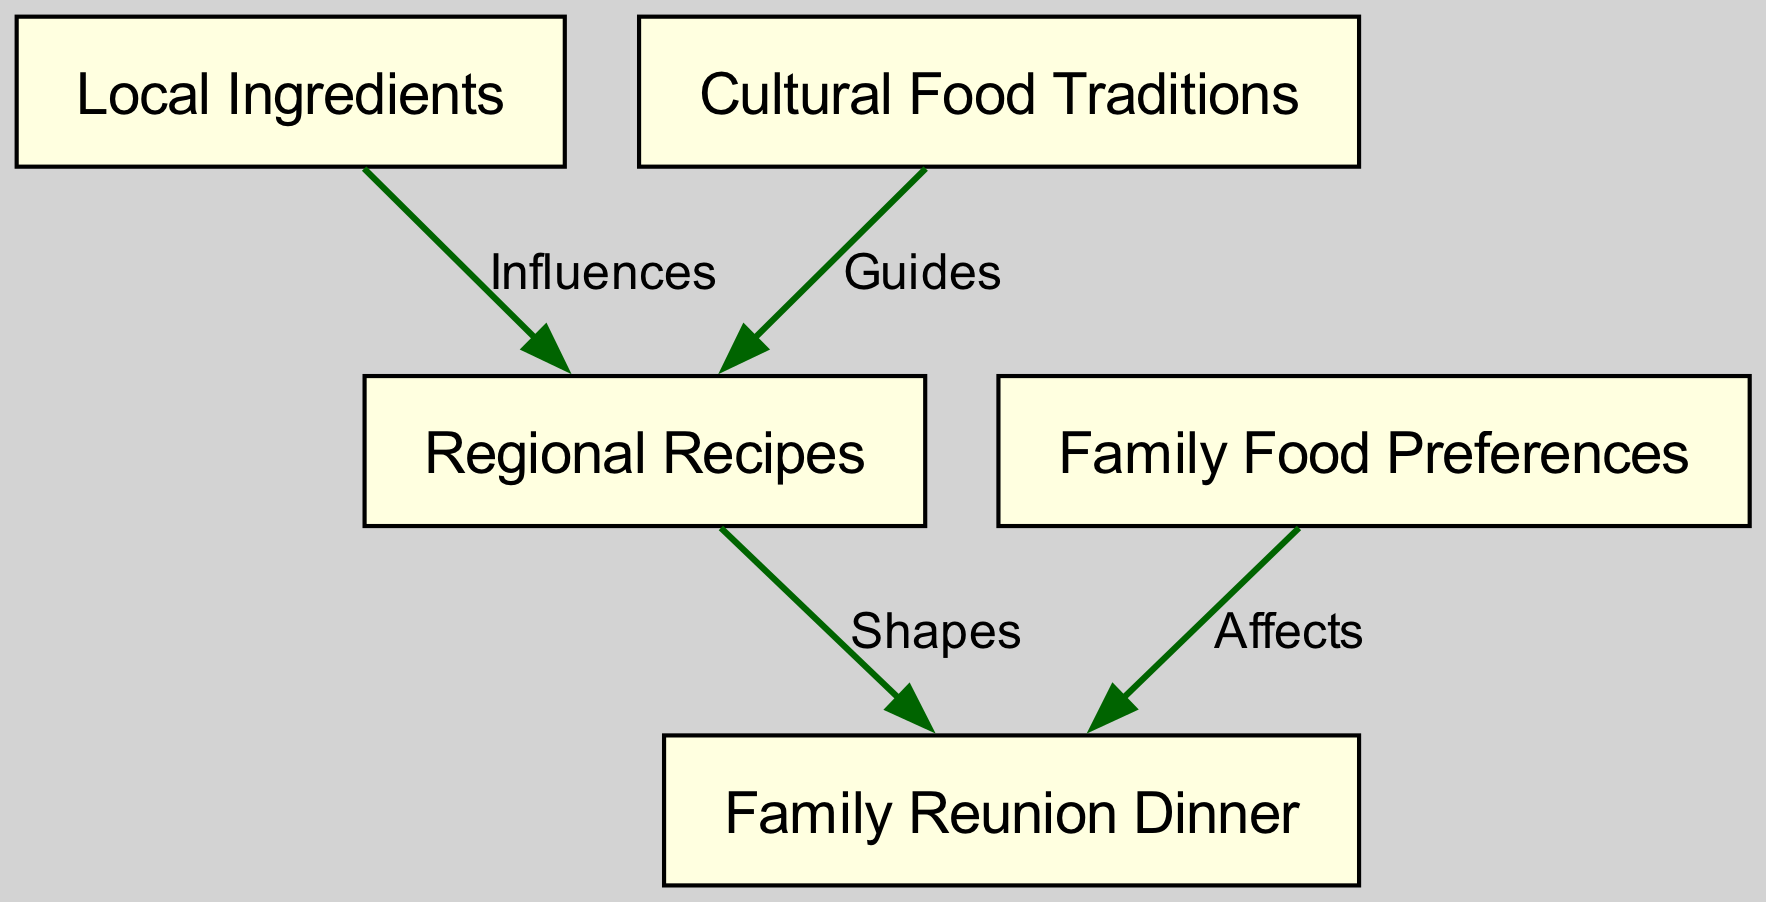What is the primary event represented in the diagram? The main event depicted in the diagram is the "Family Reunion Dinner," which is the focal point of the relationships illustrated.
Answer: Family Reunion Dinner How many nodes are present in the diagram? The diagram contains five nodes, which represent key concepts related to food and family gatherings.
Answer: 5 What does "Local Ingredients" influence? "Local Ingredients" influences "Regional Recipes," indicating that the availability and type of local produce shape the recipes used in various regions.
Answer: Regional Recipes Which node guides "Regional Recipes"? The node that guides "Regional Recipes" is "Cultural Food Traditions," suggesting that cultural practices inform local cooking methods and dishes.
Answer: Cultural Food Traditions How do "Family Food Preferences" affect the dinner? "Family Food Preferences" affect the "Family Reunion Dinner" by directly influencing what dishes and foods are chosen for the meal, aligning with the tastes of family members.
Answer: Affects What is the relationship between "Cultural Food Traditions" and "Regional Recipes"? The relationship is that "Cultural Food Traditions" guides "Regional Recipes," indicating that the cultural context provides direction for recipe development in different regions.
Answer: Guides How does the concept of "Local Ingredients" shape the "Family Reunion Dinner"? "Local Ingredients" shapes the "Family Reunion Dinner" by influencing the types of dishes prepared, ensuring they reflect the available ingredients in the region.
Answer: Shapes Which node does "Cultural Food Traditions" connect to aside from "Regional Recipes"? "Cultural Food Traditions" connects exclusively to "Regional Recipes" within the diagram, as there are no other direct relationships shown for this node.
Answer: Regional Recipes What type of influence is represented by the edge from "Local Ingredients" to "Regional Recipes"? The edge from "Local Ingredients" to "Regional Recipes" represents an "Influences" type of influence, indicating a direct impact on the formation of regional dishes.
Answer: Influences 